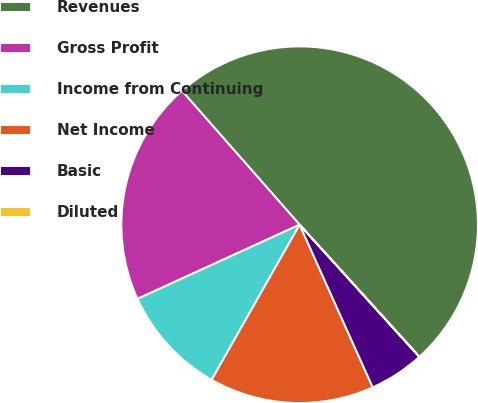Convert chart. <chart><loc_0><loc_0><loc_500><loc_500><pie_chart><fcel>Revenues<fcel>Gross Profit<fcel>Income from Continuing<fcel>Net Income<fcel>Basic<fcel>Diluted<nl><fcel>49.76%<fcel>20.35%<fcel>9.96%<fcel>14.94%<fcel>4.99%<fcel>0.01%<nl></chart> 